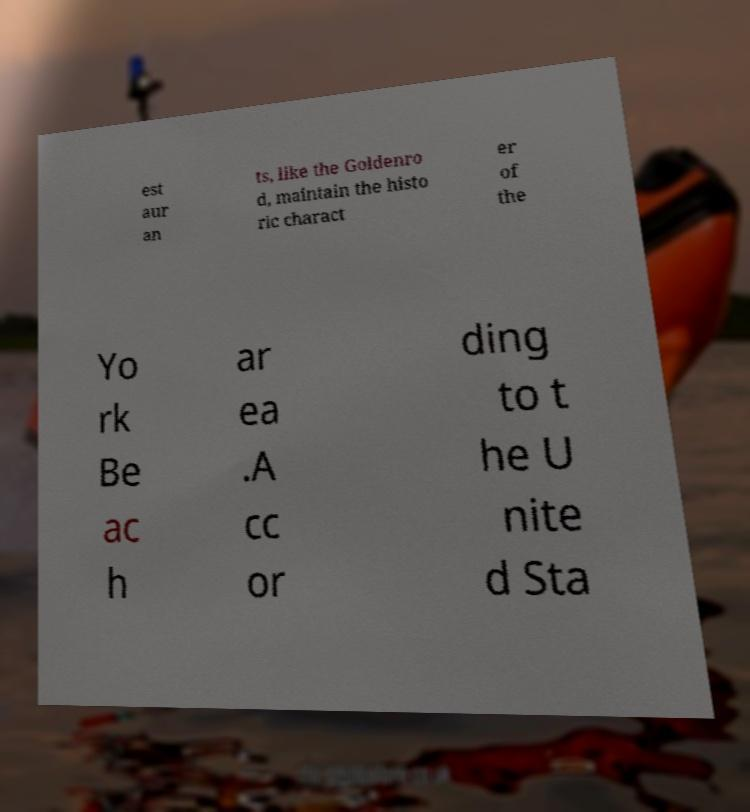Can you accurately transcribe the text from the provided image for me? est aur an ts, like the Goldenro d, maintain the histo ric charact er of the Yo rk Be ac h ar ea .A cc or ding to t he U nite d Sta 